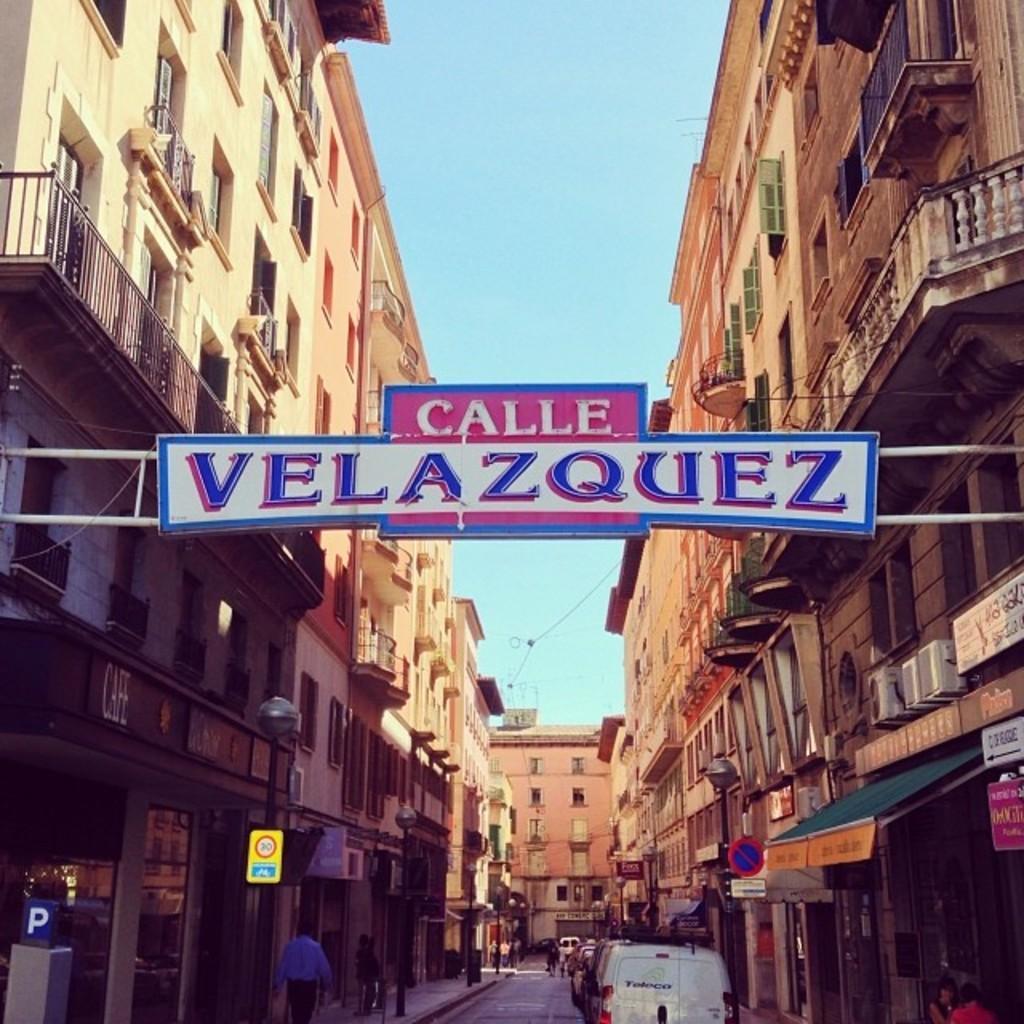Could you give a brief overview of what you see in this image? In this image, in the middle there is a board, text, arch. In the background there are buildings, vehicles, people, street lights, sign boards, road, sky. 